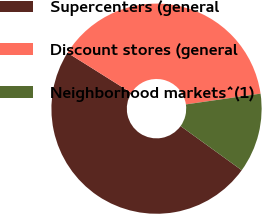<chart> <loc_0><loc_0><loc_500><loc_500><pie_chart><fcel>Supercenters (general<fcel>Discount stores (general<fcel>Neighborhood markets^(1)<nl><fcel>48.96%<fcel>38.79%<fcel>12.24%<nl></chart> 